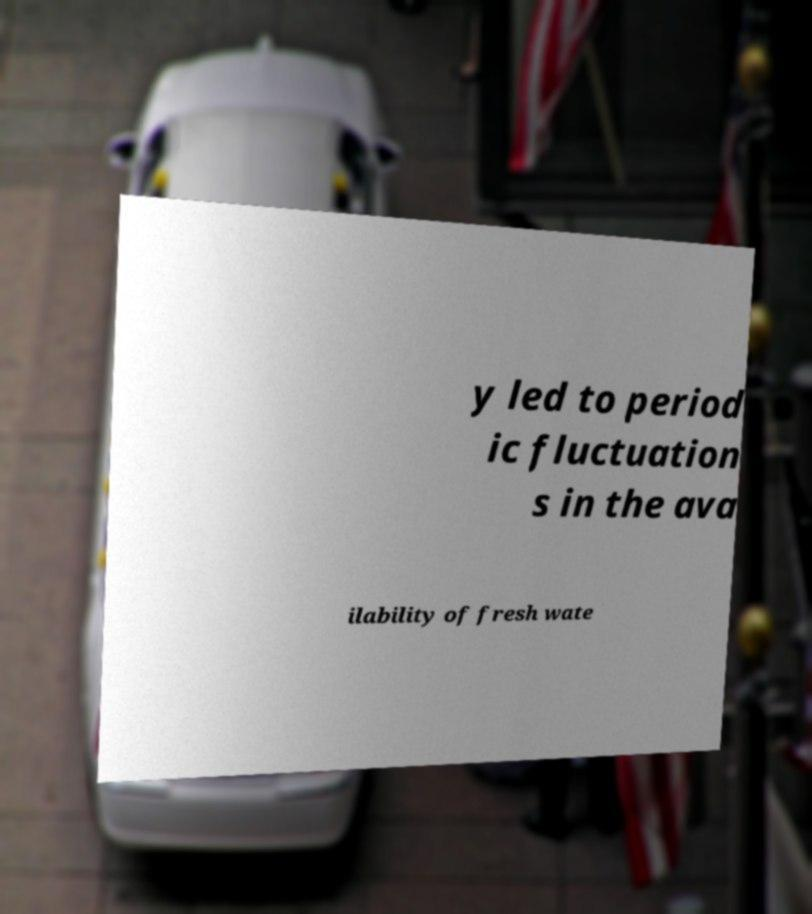What messages or text are displayed in this image? I need them in a readable, typed format. y led to period ic fluctuation s in the ava ilability of fresh wate 